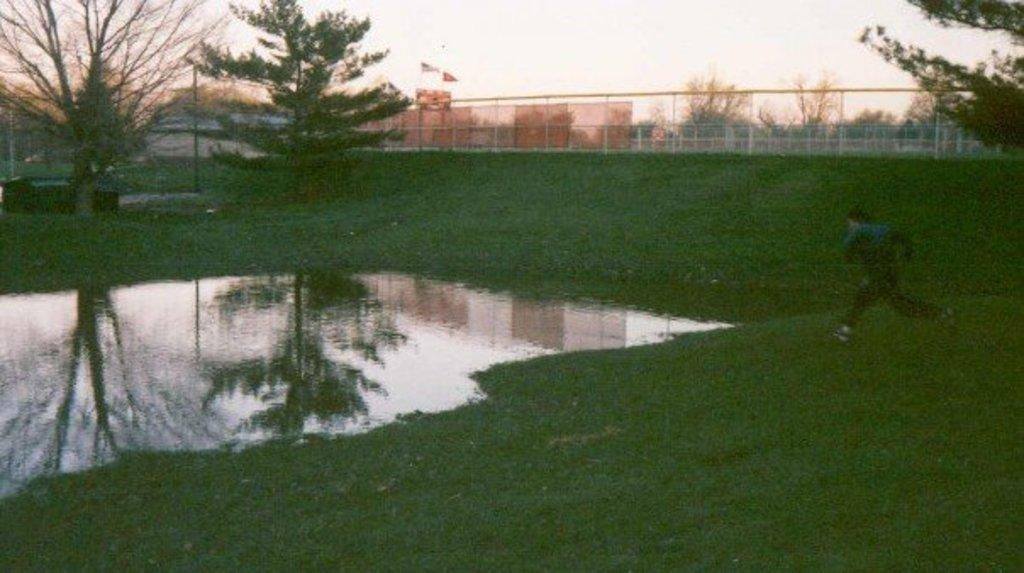How would you describe the overall appearance of the image? The image is hazy. What is the person in the image doing? A: There is a person running from the right side of the image. What can be seen in the middle of the image? There is a water body in the middle of the image. What is visible in the background of the image? Trees, buildings, a pole, and the sky are visible in the background of the image. How is the area in the image defined or marked? The area is surrounded by a boundary. What type of apple can be seen hanging from the pole in the image? There is no apple present in the image, and therefore no such activity can be observed. 